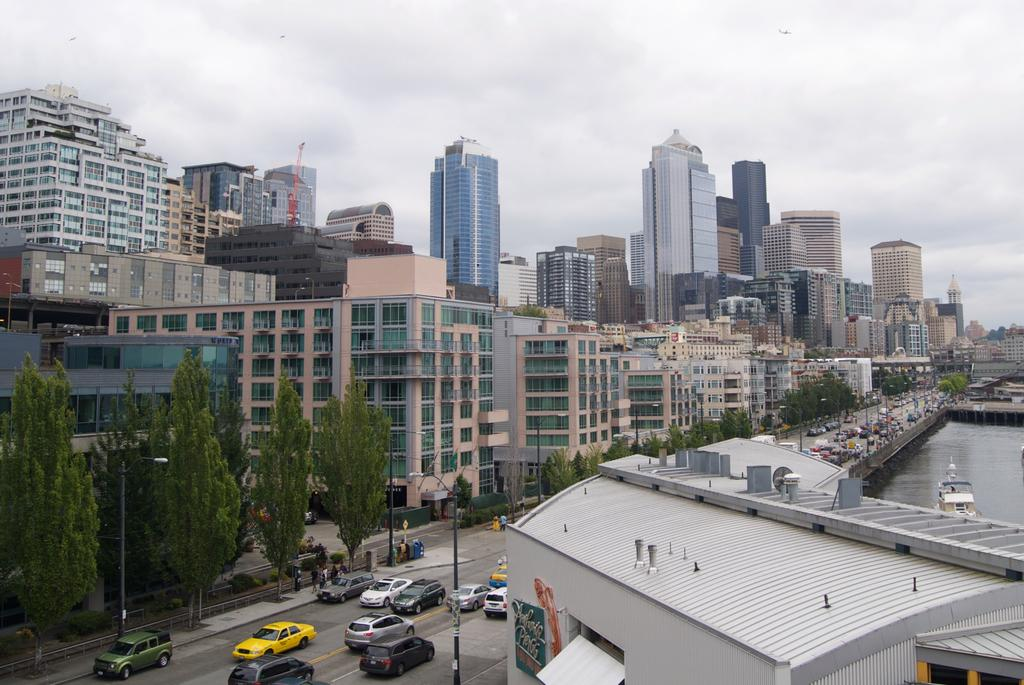How many people are in the image? There is a group of people in the image, but the exact number is not specified. What type of natural elements can be seen in the image? There are trees in the image. What type of man-made structures are present in the image? There are poles, vehicles, buildings, and a crane in the image. What type of watercraft can be seen in the background of the image? There is a boat on the water in the background of the image. Can you see any caves in the image? There is no mention of a cave in the image, so it cannot be confirmed or denied. What color is the brain of the person in the image? There is no mention of a brain in the image, so it cannot be confirmed or denied. 